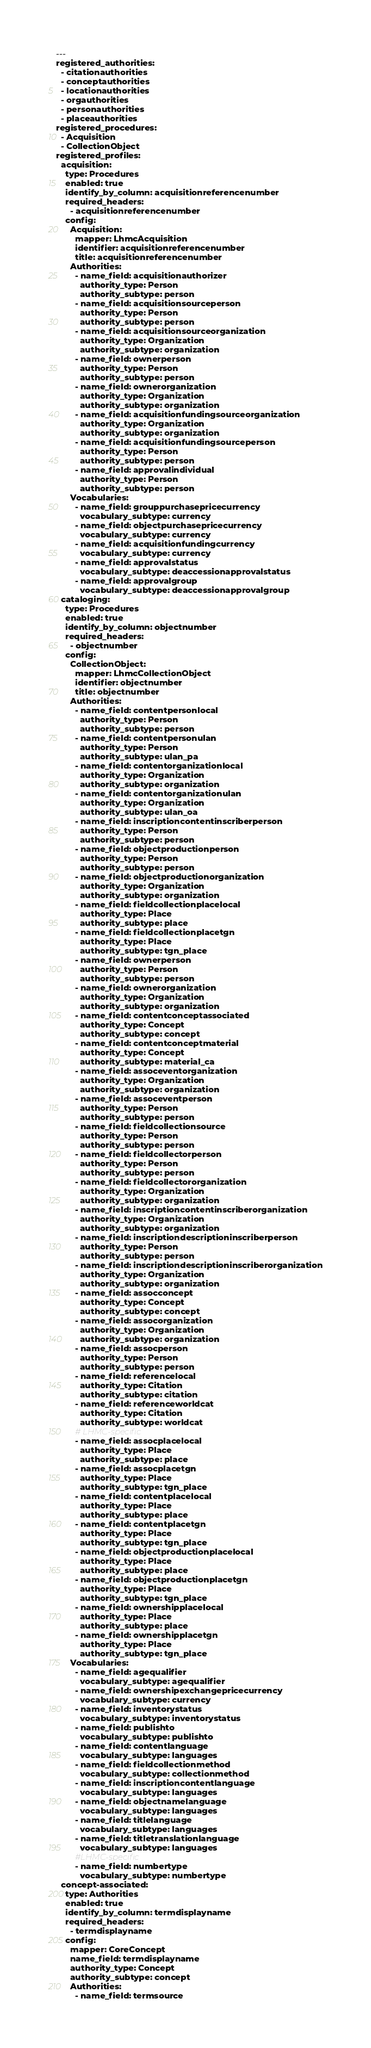Convert code to text. <code><loc_0><loc_0><loc_500><loc_500><_YAML_>---
registered_authorities:
  - citationauthorities
  - conceptauthorities
  - locationauthorities
  - orgauthorities
  - personauthorities
  - placeauthorities
registered_procedures:
  - Acquisition
  - CollectionObject
registered_profiles:
  acquisition:
    type: Procedures
    enabled: true
    identify_by_column: acquisitionreferencenumber
    required_headers:
      - acquisitionreferencenumber
    config:
      Acquisition:
        mapper: LhmcAcquisition
        identifier: acquisitionreferencenumber
        title: acquisitionreferencenumber
      Authorities:
        - name_field: acquisitionauthorizer
          authority_type: Person
          authority_subtype: person
        - name_field: acquisitionsourceperson
          authority_type: Person
          authority_subtype: person
        - name_field: acquisitionsourceorganization
          authority_type: Organization
          authority_subtype: organization
        - name_field: ownerperson
          authority_type: Person
          authority_subtype: person
        - name_field: ownerorganization
          authority_type: Organization
          authority_subtype: organization
        - name_field: acquisitionfundingsourceorganization
          authority_type: Organization
          authority_subtype: organization
        - name_field: acquisitionfundingsourceperson
          authority_type: Person
          authority_subtype: person
        - name_field: approvalindividual
          authority_type: Person
          authority_subtype: person
      Vocabularies:
        - name_field: grouppurchasepricecurrency
          vocabulary_subtype: currency
        - name_field: objectpurchasepricecurrency
          vocabulary_subtype: currency
        - name_field: acquisitionfundingcurrency
          vocabulary_subtype: currency
        - name_field: approvalstatus
          vocabulary_subtype: deaccessionapprovalstatus
        - name_field: approvalgroup
          vocabulary_subtype: deaccessionapprovalgroup
  cataloging:
    type: Procedures
    enabled: true
    identify_by_column: objectnumber
    required_headers:
      - objectnumber
    config:
      CollectionObject:
        mapper: LhmcCollectionObject
        identifier: objectnumber
        title: objectnumber
      Authorities:
        - name_field: contentpersonlocal
          authority_type: Person
          authority_subtype: person
        - name_field: contentpersonulan
          authority_type: Person
          authority_subtype: ulan_pa
        - name_field: contentorganizationlocal
          authority_type: Organization
          authority_subtype: organization
        - name_field: contentorganizationulan
          authority_type: Organization
          authority_subtype: ulan_oa
        - name_field: inscriptioncontentinscriberperson
          authority_type: Person
          authority_subtype: person
        - name_field: objectproductionperson
          authority_type: Person
          authority_subtype: person
        - name_field: objectproductionorganization
          authority_type: Organization
          authority_subtype: organization
        - name_field: fieldcollectionplacelocal
          authority_type: Place
          authority_subtype: place
        - name_field: fieldcollectionplacetgn
          authority_type: Place
          authority_subtype: tgn_place
        - name_field: ownerperson
          authority_type: Person
          authority_subtype: person
        - name_field: ownerorganization
          authority_type: Organization
          authority_subtype: organization
        - name_field: contentconceptassociated
          authority_type: Concept
          authority_subtype: concept
        - name_field: contentconceptmaterial
          authority_type: Concept
          authority_subtype: material_ca
        - name_field: assoceventorganization
          authority_type: Organization
          authority_subtype: organization
        - name_field: assoceventperson
          authority_type: Person
          authority_subtype: person
        - name_field: fieldcollectionsource
          authority_type: Person
          authority_subtype: person
        - name_field: fieldcollectorperson
          authority_type: Person
          authority_subtype: person
        - name_field: fieldcollectororganization
          authority_type: Organization
          authority_subtype: organization
        - name_field: inscriptioncontentinscriberorganization
          authority_type: Organization
          authority_subtype: organization
        - name_field: inscriptiondescriptioninscriberperson
          authority_type: Person
          authority_subtype: person
        - name_field: inscriptiondescriptioninscriberorganization
          authority_type: Organization
          authority_subtype: organization
        - name_field: assocconcept
          authority_type: Concept
          authority_subtype: concept
        - name_field: assocorganization
          authority_type: Organization
          authority_subtype: organization
        - name_field: assocperson
          authority_type: Person
          authority_subtype: person
        - name_field: referencelocal
          authority_type: Citation
          authority_subtype: citation
        - name_field: referenceworldcat
          authority_type: Citation
          authority_subtype: worldcat
        # LHMC-specific
        - name_field: assocplacelocal
          authority_type: Place
          authority_subtype: place
        - name_field: assocplacetgn
          authority_type: Place
          authority_subtype: tgn_place
        - name_field: contentplacelocal
          authority_type: Place
          authority_subtype: place
        - name_field: contentplacetgn
          authority_type: Place
          authority_subtype: tgn_place
        - name_field: objectproductionplacelocal
          authority_type: Place
          authority_subtype: place
        - name_field: objectproductionplacetgn
          authority_type: Place
          authority_subtype: tgn_place
        - name_field: ownershipplacelocal
          authority_type: Place
          authority_subtype: place
        - name_field: ownershipplacetgn
          authority_type: Place
          authority_subtype: tgn_place
      Vocabularies:
        - name_field: agequalifier
          vocabulary_subtype: agequalifier
        - name_field: ownershipexchangepricecurrency
          vocabulary_subtype: currency
        - name_field: inventorystatus
          vocabulary_subtype: inventorystatus
        - name_field: publishto
          vocabulary_subtype: publishto
        - name_field: contentlanguage
          vocabulary_subtype: languages
        - name_field: fieldcollectionmethod
          vocabulary_subtype: collectionmethod
        - name_field: inscriptioncontentlanguage
          vocabulary_subtype: languages
        - name_field: objectnamelanguage
          vocabulary_subtype: languages
        - name_field: titlelanguage
          vocabulary_subtype: languages
        - name_field: titletranslationlanguage
          vocabulary_subtype: languages
        #LHMC-specific
        - name_field: numbertype
          vocabulary_subtype: numbertype
  concept-associated:
    type: Authorities
    enabled: true
    identify_by_column: termdisplayname
    required_headers:
      - termdisplayname
    config:
      mapper: CoreConcept
      name_field: termdisplayname
      authority_type: Concept
      authority_subtype: concept
      Authorities:
        - name_field: termsource</code> 